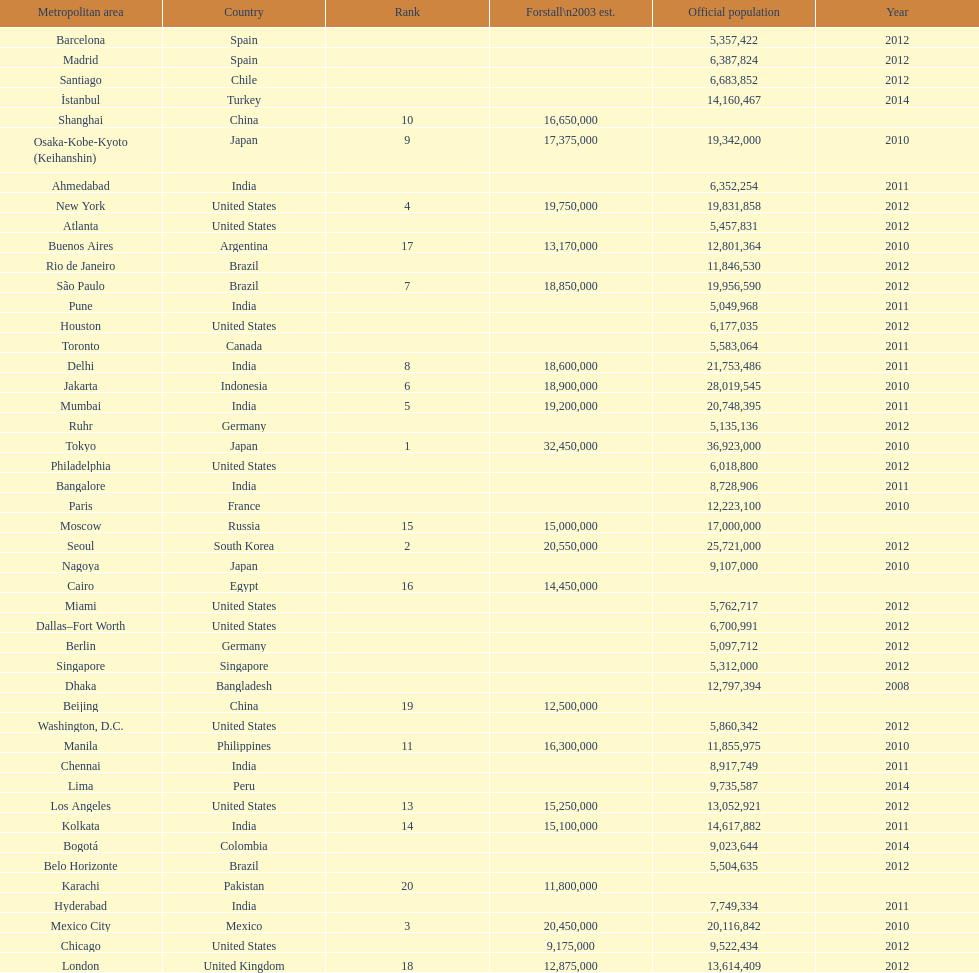Identify a city in the same nation as bangalore. Ahmedabad. 